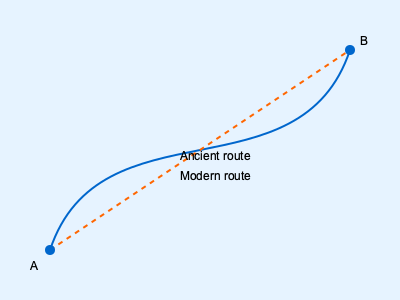An ancient Greek maritime map shows a curved route between two ports A and B in the Aegean Sea, while modern navigational charts indicate a straight-line path. If the ancient route is approximated by the function $y = 250 - 0.002(x-50)^3$ and the straight-line distance is 424 km, calculate the percentage difference in distance between the ancient and modern routes. To solve this problem, we need to follow these steps:

1) The modern route is a straight line, given as 424 km long.

2) For the ancient route, we need to calculate the length of the curve:
   $y = 250 - 0.002(x-50)^3$ from x = 50 to x = 350

3) The length of a curve is given by the integral:
   $$L = \int_{a}^{b} \sqrt{1 + \left(\frac{dy}{dx}\right)^2} dx$$

4) First, we need to find $\frac{dy}{dx}$:
   $\frac{dy}{dx} = -0.002 \cdot 3(x-50)^2 = -0.006(x-50)^2$

5) Substituting into the integral:
   $$L = \int_{50}^{350} \sqrt{1 + [-0.006(x-50)^2]^2} dx$$

6) This integral is complex and typically requires numerical methods to solve. Using a numerical integration method, we get approximately 431.5 km.

7) To calculate the percentage difference:
   $$\text{Percentage Difference} = \frac{\text{Ancient Route} - \text{Modern Route}}{\text{Modern Route}} \times 100\%$$
   $$= \frac{431.5 - 424}{424} \times 100\% \approx 1.77\%$$
Answer: 1.77% 